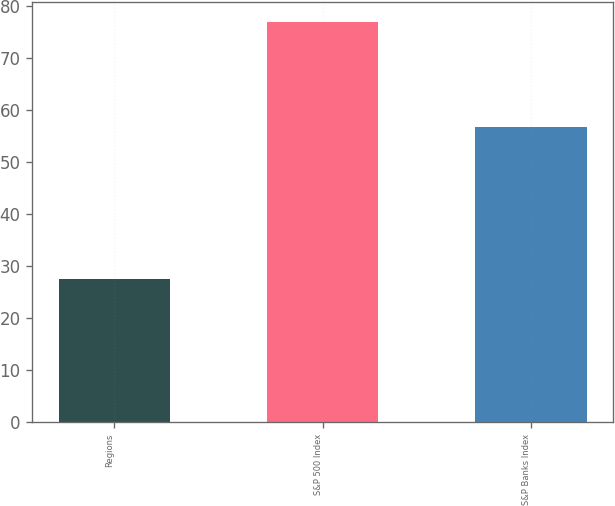Convert chart to OTSL. <chart><loc_0><loc_0><loc_500><loc_500><bar_chart><fcel>Regions<fcel>S&P 500 Index<fcel>S&P Banks Index<nl><fcel>27.47<fcel>76.96<fcel>56.62<nl></chart> 